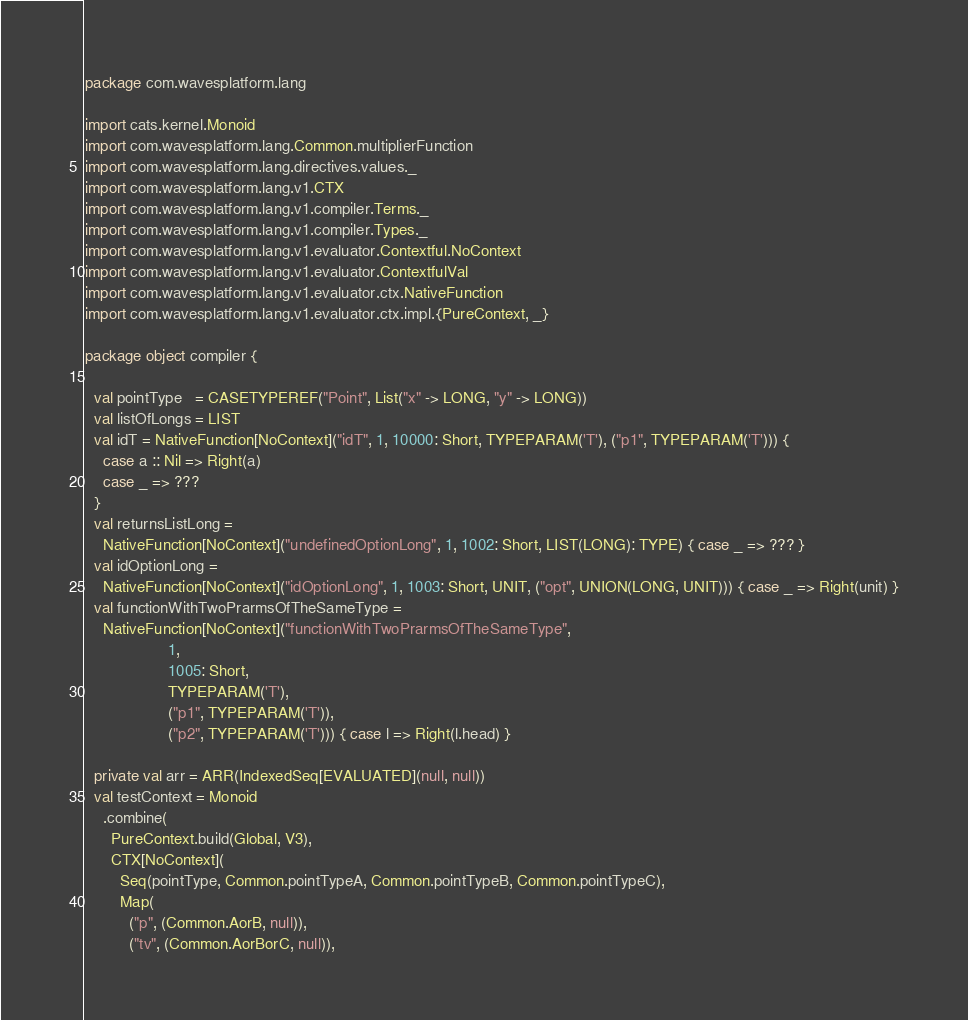Convert code to text. <code><loc_0><loc_0><loc_500><loc_500><_Scala_>package com.wavesplatform.lang

import cats.kernel.Monoid
import com.wavesplatform.lang.Common.multiplierFunction
import com.wavesplatform.lang.directives.values._
import com.wavesplatform.lang.v1.CTX
import com.wavesplatform.lang.v1.compiler.Terms._
import com.wavesplatform.lang.v1.compiler.Types._
import com.wavesplatform.lang.v1.evaluator.Contextful.NoContext
import com.wavesplatform.lang.v1.evaluator.ContextfulVal
import com.wavesplatform.lang.v1.evaluator.ctx.NativeFunction
import com.wavesplatform.lang.v1.evaluator.ctx.impl.{PureContext, _}

package object compiler {

  val pointType   = CASETYPEREF("Point", List("x" -> LONG, "y" -> LONG))
  val listOfLongs = LIST
  val idT = NativeFunction[NoContext]("idT", 1, 10000: Short, TYPEPARAM('T'), ("p1", TYPEPARAM('T'))) {
    case a :: Nil => Right(a)
    case _ => ???
  }
  val returnsListLong =
    NativeFunction[NoContext]("undefinedOptionLong", 1, 1002: Short, LIST(LONG): TYPE) { case _ => ??? }
  val idOptionLong =
    NativeFunction[NoContext]("idOptionLong", 1, 1003: Short, UNIT, ("opt", UNION(LONG, UNIT))) { case _ => Right(unit) }
  val functionWithTwoPrarmsOfTheSameType =
    NativeFunction[NoContext]("functionWithTwoPrarmsOfTheSameType",
                   1,
                   1005: Short,
                   TYPEPARAM('T'),
                   ("p1", TYPEPARAM('T')),
                   ("p2", TYPEPARAM('T'))) { case l => Right(l.head) }

  private val arr = ARR(IndexedSeq[EVALUATED](null, null))
  val testContext = Monoid
    .combine(
      PureContext.build(Global, V3),
      CTX[NoContext](
        Seq(pointType, Common.pointTypeA, Common.pointTypeB, Common.pointTypeC),
        Map(
          ("p", (Common.AorB, null)),
          ("tv", (Common.AorBorC, null)),</code> 